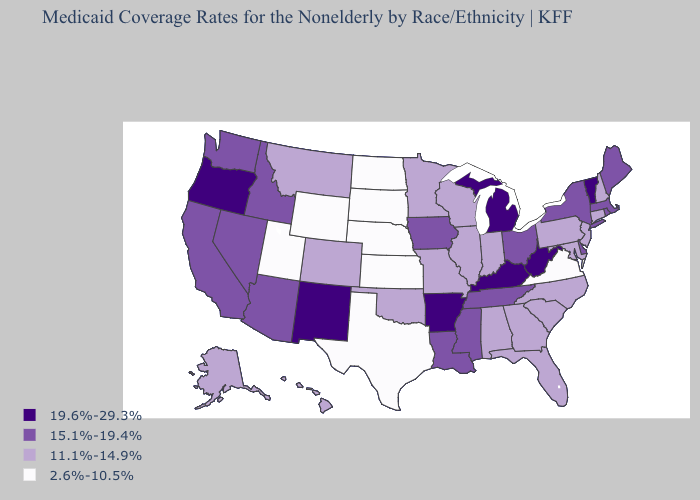What is the value of Michigan?
Answer briefly. 19.6%-29.3%. Which states have the lowest value in the South?
Give a very brief answer. Texas, Virginia. What is the value of Michigan?
Be succinct. 19.6%-29.3%. How many symbols are there in the legend?
Keep it brief. 4. Name the states that have a value in the range 11.1%-14.9%?
Concise answer only. Alabama, Alaska, Colorado, Connecticut, Florida, Georgia, Hawaii, Illinois, Indiana, Maryland, Minnesota, Missouri, Montana, New Hampshire, New Jersey, North Carolina, Oklahoma, Pennsylvania, South Carolina, Wisconsin. What is the value of New Hampshire?
Concise answer only. 11.1%-14.9%. Which states hav the highest value in the South?
Be succinct. Arkansas, Kentucky, West Virginia. Does the map have missing data?
Keep it brief. No. Among the states that border New Hampshire , which have the highest value?
Give a very brief answer. Vermont. What is the lowest value in the Northeast?
Concise answer only. 11.1%-14.9%. Name the states that have a value in the range 15.1%-19.4%?
Answer briefly. Arizona, California, Delaware, Idaho, Iowa, Louisiana, Maine, Massachusetts, Mississippi, Nevada, New York, Ohio, Rhode Island, Tennessee, Washington. How many symbols are there in the legend?
Be succinct. 4. What is the lowest value in states that border Connecticut?
Write a very short answer. 15.1%-19.4%. What is the value of Maine?
Keep it brief. 15.1%-19.4%. Does Virginia have the lowest value in the South?
Concise answer only. Yes. 